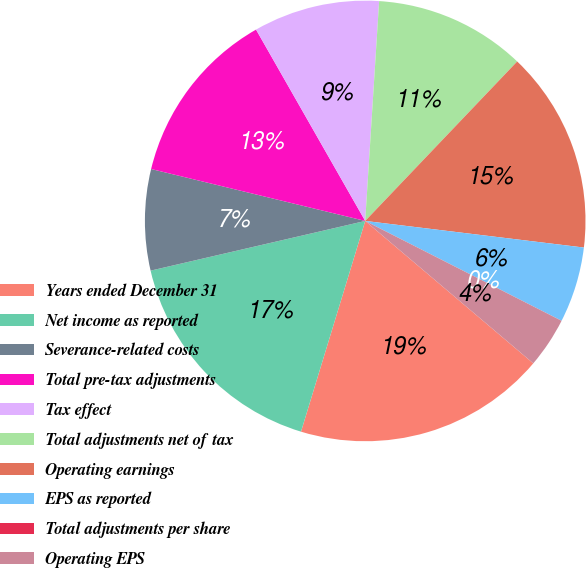Convert chart to OTSL. <chart><loc_0><loc_0><loc_500><loc_500><pie_chart><fcel>Years ended December 31<fcel>Net income as reported<fcel>Severance-related costs<fcel>Total pre-tax adjustments<fcel>Tax effect<fcel>Total adjustments net of tax<fcel>Operating earnings<fcel>EPS as reported<fcel>Total adjustments per share<fcel>Operating EPS<nl><fcel>18.52%<fcel>16.67%<fcel>7.41%<fcel>12.96%<fcel>9.26%<fcel>11.11%<fcel>14.81%<fcel>5.56%<fcel>0.0%<fcel>3.7%<nl></chart> 